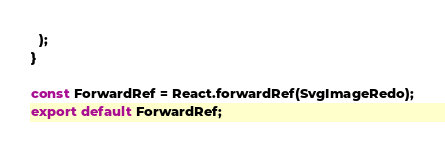Convert code to text. <code><loc_0><loc_0><loc_500><loc_500><_TypeScript_>  );
}

const ForwardRef = React.forwardRef(SvgImageRedo);
export default ForwardRef;
</code> 